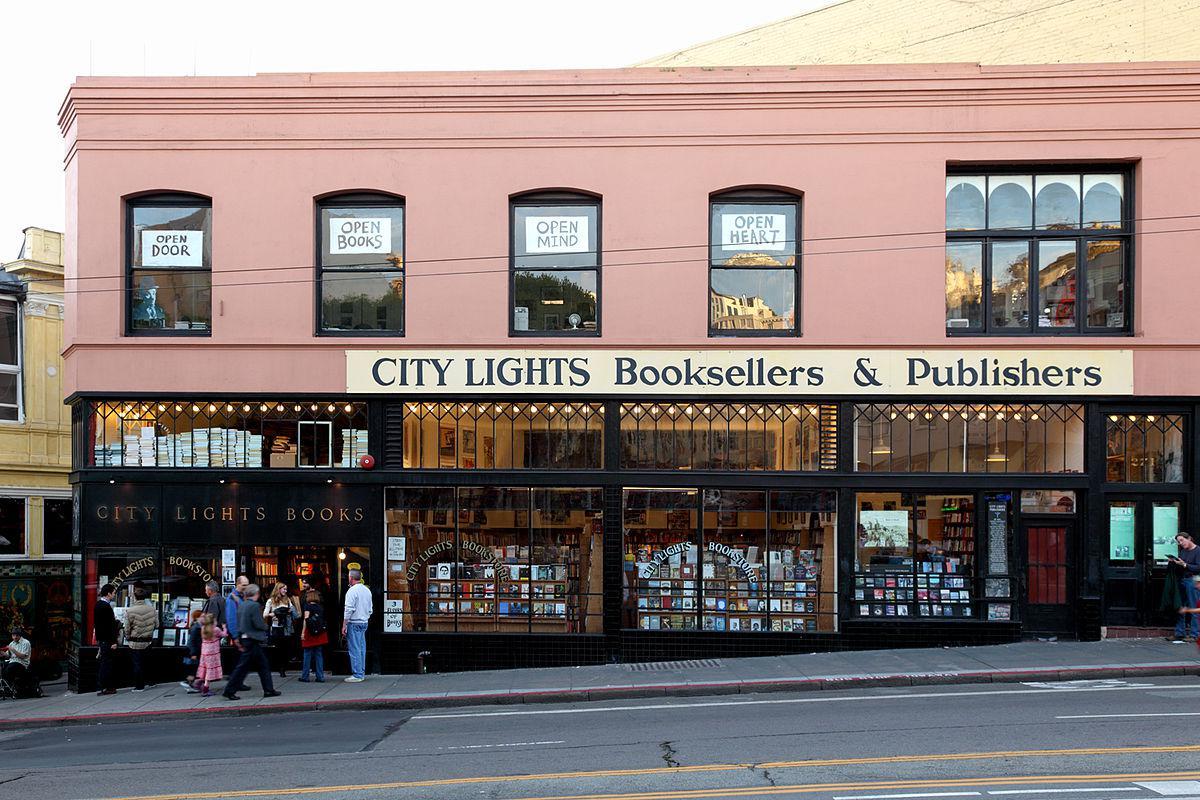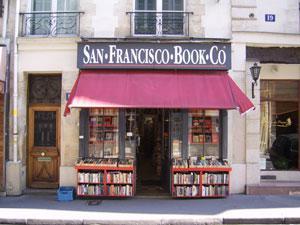The first image is the image on the left, the second image is the image on the right. Analyze the images presented: Is the assertion "There are two set of red bookshelves outside filled with books, under a red awning." valid? Answer yes or no. Yes. The first image is the image on the left, the second image is the image on the right. For the images shown, is this caption "An awning hangs over the business in the image on the right." true? Answer yes or no. Yes. 